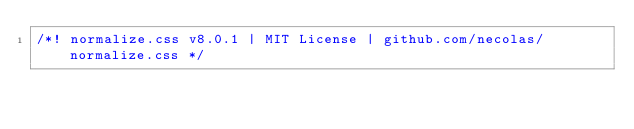Convert code to text. <code><loc_0><loc_0><loc_500><loc_500><_CSS_>/*! normalize.css v8.0.1 | MIT License | github.com/necolas/normalize.css */</code> 